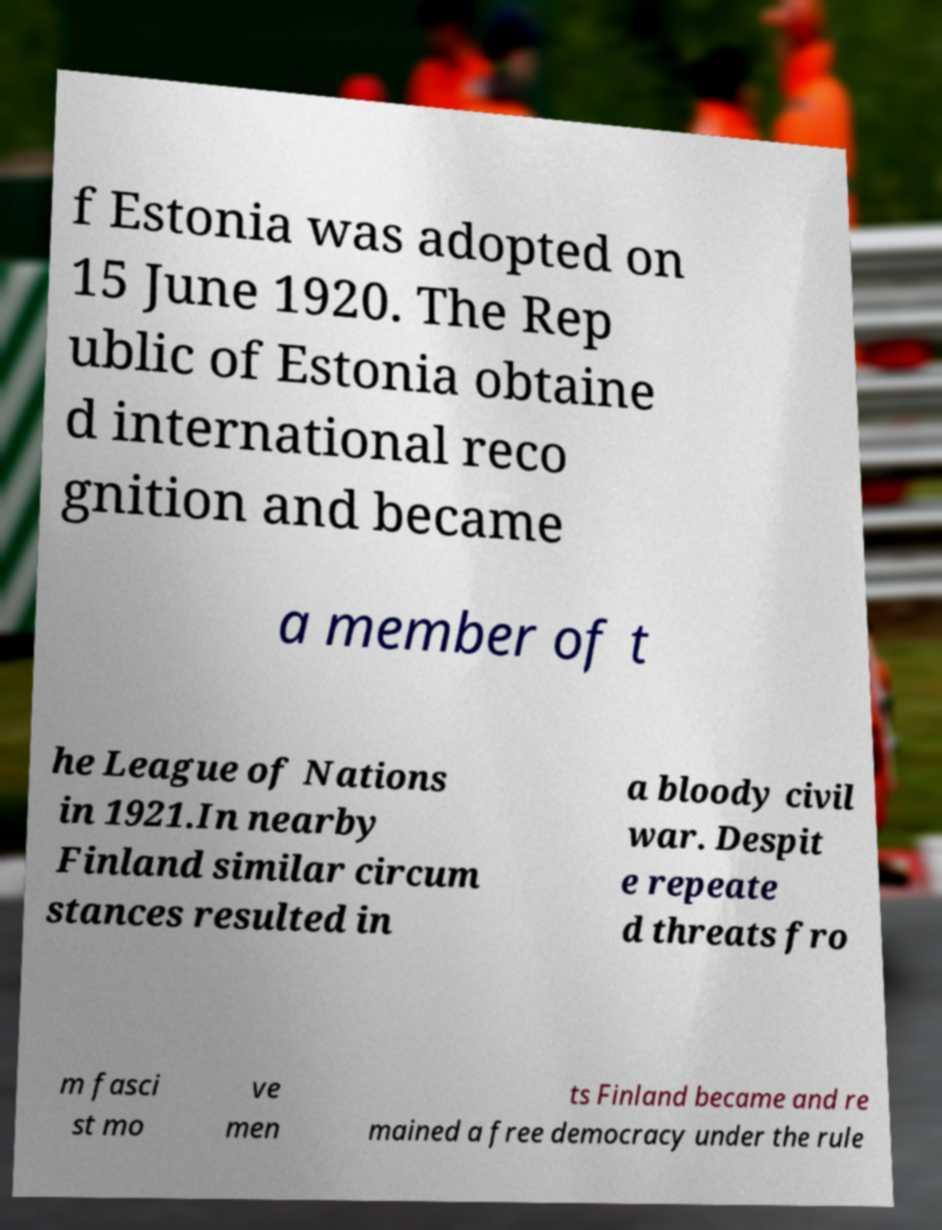Can you accurately transcribe the text from the provided image for me? f Estonia was adopted on 15 June 1920. The Rep ublic of Estonia obtaine d international reco gnition and became a member of t he League of Nations in 1921.In nearby Finland similar circum stances resulted in a bloody civil war. Despit e repeate d threats fro m fasci st mo ve men ts Finland became and re mained a free democracy under the rule 